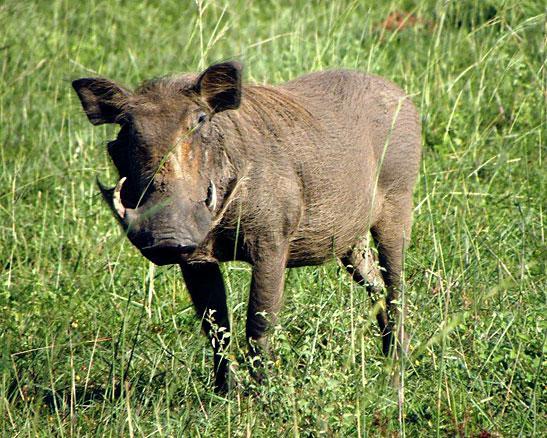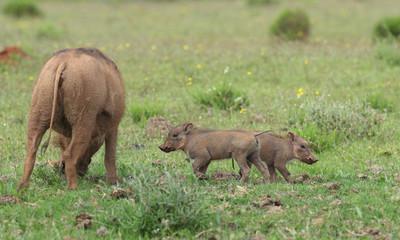The first image is the image on the left, the second image is the image on the right. Evaluate the accuracy of this statement regarding the images: "One of the images contains only one boar.". Is it true? Answer yes or no. Yes. 